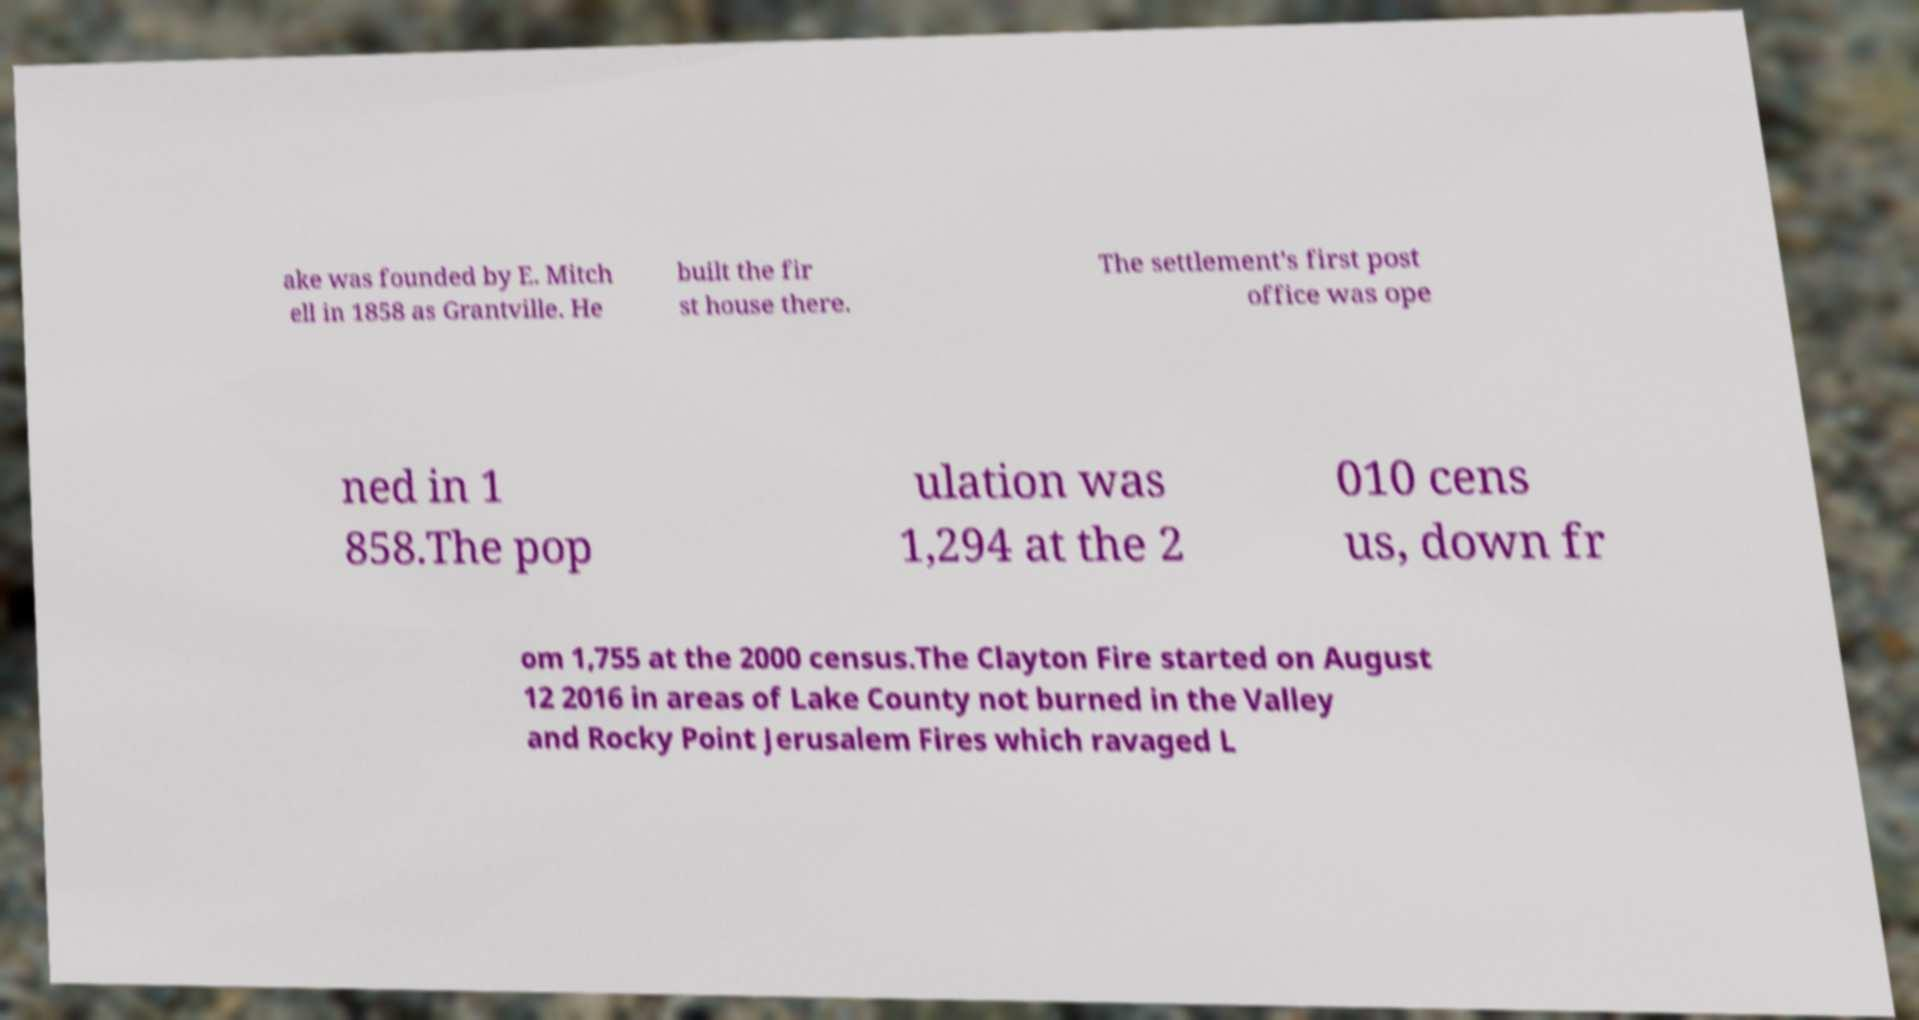What messages or text are displayed in this image? I need them in a readable, typed format. ake was founded by E. Mitch ell in 1858 as Grantville. He built the fir st house there. The settlement's first post office was ope ned in 1 858.The pop ulation was 1,294 at the 2 010 cens us, down fr om 1,755 at the 2000 census.The Clayton Fire started on August 12 2016 in areas of Lake County not burned in the Valley and Rocky Point Jerusalem Fires which ravaged L 